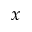<formula> <loc_0><loc_0><loc_500><loc_500>x</formula> 